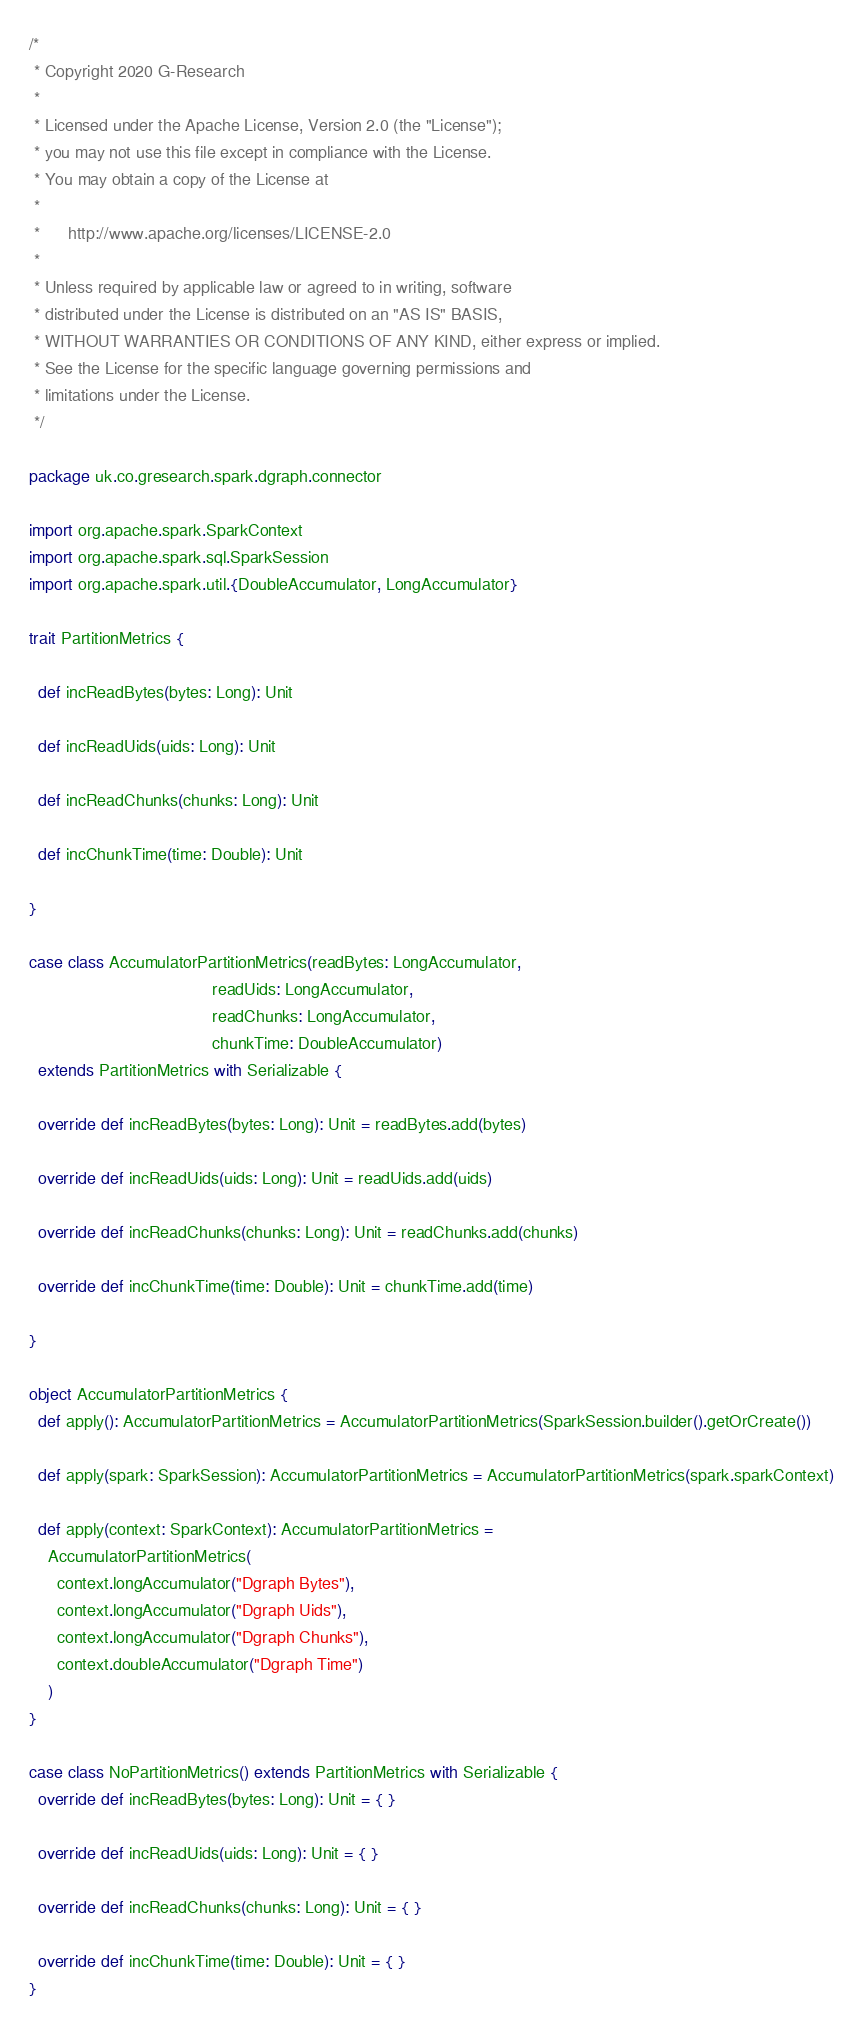<code> <loc_0><loc_0><loc_500><loc_500><_Scala_>/*
 * Copyright 2020 G-Research
 *
 * Licensed under the Apache License, Version 2.0 (the "License");
 * you may not use this file except in compliance with the License.
 * You may obtain a copy of the License at
 *
 *      http://www.apache.org/licenses/LICENSE-2.0
 *
 * Unless required by applicable law or agreed to in writing, software
 * distributed under the License is distributed on an "AS IS" BASIS,
 * WITHOUT WARRANTIES OR CONDITIONS OF ANY KIND, either express or implied.
 * See the License for the specific language governing permissions and
 * limitations under the License.
 */

package uk.co.gresearch.spark.dgraph.connector

import org.apache.spark.SparkContext
import org.apache.spark.sql.SparkSession
import org.apache.spark.util.{DoubleAccumulator, LongAccumulator}

trait PartitionMetrics {

  def incReadBytes(bytes: Long): Unit

  def incReadUids(uids: Long): Unit

  def incReadChunks(chunks: Long): Unit

  def incChunkTime(time: Double): Unit

}

case class AccumulatorPartitionMetrics(readBytes: LongAccumulator,
                                       readUids: LongAccumulator,
                                       readChunks: LongAccumulator,
                                       chunkTime: DoubleAccumulator)
  extends PartitionMetrics with Serializable {

  override def incReadBytes(bytes: Long): Unit = readBytes.add(bytes)

  override def incReadUids(uids: Long): Unit = readUids.add(uids)

  override def incReadChunks(chunks: Long): Unit = readChunks.add(chunks)

  override def incChunkTime(time: Double): Unit = chunkTime.add(time)

}

object AccumulatorPartitionMetrics {
  def apply(): AccumulatorPartitionMetrics = AccumulatorPartitionMetrics(SparkSession.builder().getOrCreate())

  def apply(spark: SparkSession): AccumulatorPartitionMetrics = AccumulatorPartitionMetrics(spark.sparkContext)

  def apply(context: SparkContext): AccumulatorPartitionMetrics =
    AccumulatorPartitionMetrics(
      context.longAccumulator("Dgraph Bytes"),
      context.longAccumulator("Dgraph Uids"),
      context.longAccumulator("Dgraph Chunks"),
      context.doubleAccumulator("Dgraph Time")
    )
}

case class NoPartitionMetrics() extends PartitionMetrics with Serializable {
  override def incReadBytes(bytes: Long): Unit = { }

  override def incReadUids(uids: Long): Unit = { }

  override def incReadChunks(chunks: Long): Unit = { }

  override def incChunkTime(time: Double): Unit = { }
}
</code> 